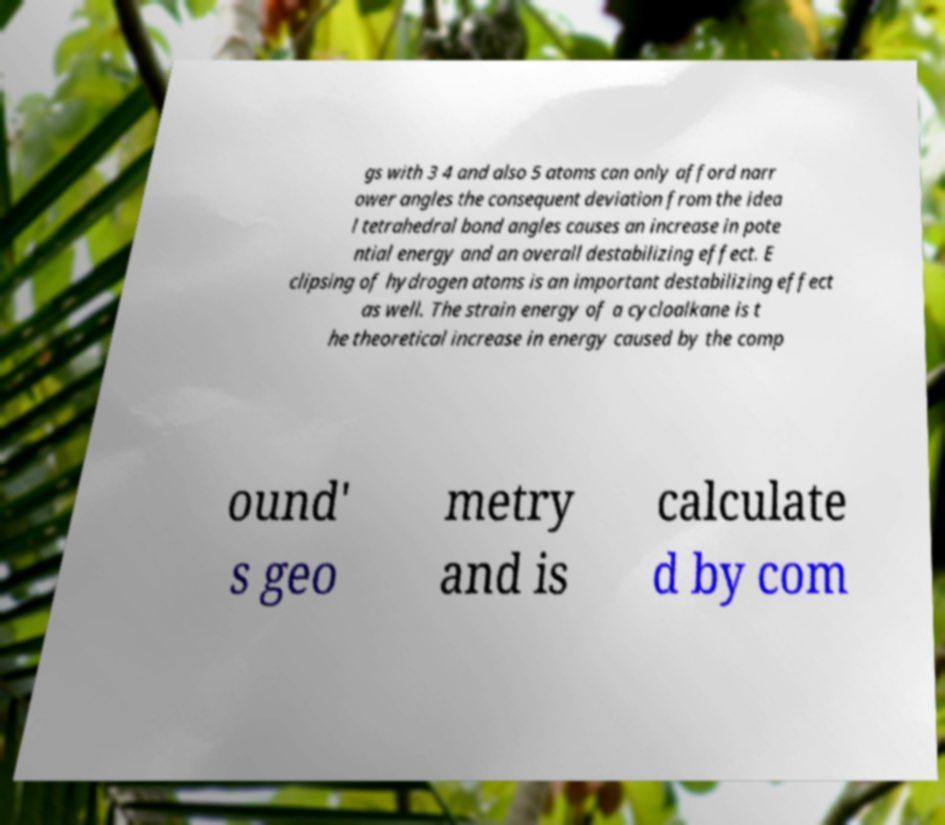For documentation purposes, I need the text within this image transcribed. Could you provide that? gs with 3 4 and also 5 atoms can only afford narr ower angles the consequent deviation from the idea l tetrahedral bond angles causes an increase in pote ntial energy and an overall destabilizing effect. E clipsing of hydrogen atoms is an important destabilizing effect as well. The strain energy of a cycloalkane is t he theoretical increase in energy caused by the comp ound' s geo metry and is calculate d by com 